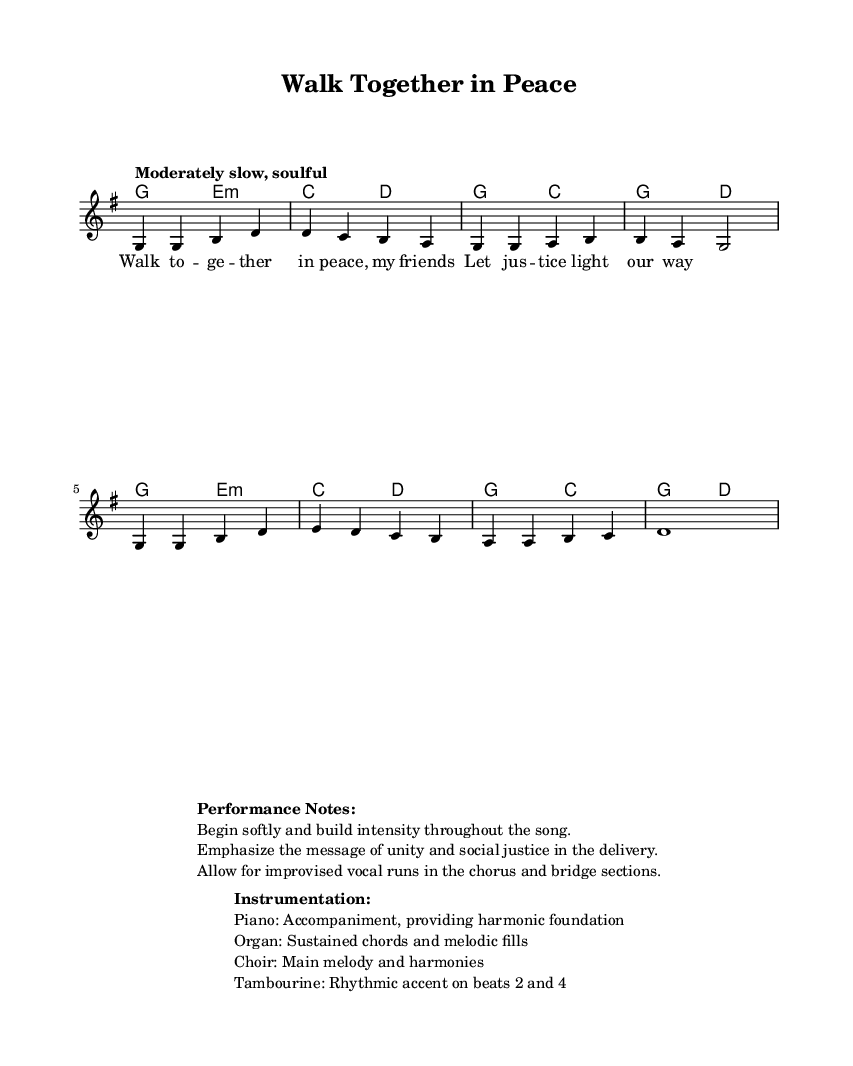What is the key signature of this music? The key signature indicates G major, which has one sharp (F#). This can be identified in the beginning of the score.
Answer: G major What is the time signature of the piece? The time signature at the beginning of the sheet music is 4/4, meaning there are four beats in each measure. This is evident from the notation placed before the melody begins.
Answer: 4/4 What is the tempo marking for this piece? The tempo marking specifies "Moderately slow, soulful" at the beginning of the music, guiding the performer on how to pace the piece. This is found right below the title in the score.
Answer: Moderately slow, soulful What is the title of the song? The title is prominently displayed at the top of the sheet music, clearly labeled. This stands out as the first line of the header information.
Answer: Walk Together in Peace How many measures are there in the melody? By counting the melody's notated measures, there are a total of eight measures represented in the score. This is determined by identifying the separation marked by vertical lines.
Answer: eight What instruments are indicated for performance? The instrumentation section clearly outlines specific roles: Piano, Organ, Choir, and Tambourine, detailing their functions within the musical arrangement. This is listed under the "Instrumentation" section provided in the markup.
Answer: Piano, Organ, Choir, Tambourine What is the primary message emphasized in the performance notes? The performance notes specifically state the importance of emphasizing the message of unity and social justice throughout the delivery of the song. This main idea is highlighted in the "Performance Notes" section.
Answer: Unity and social justice 